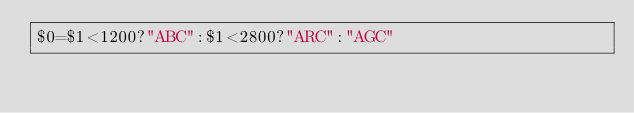Convert code to text. <code><loc_0><loc_0><loc_500><loc_500><_Awk_>$0=$1<1200?"ABC":$1<2800?"ARC":"AGC"</code> 